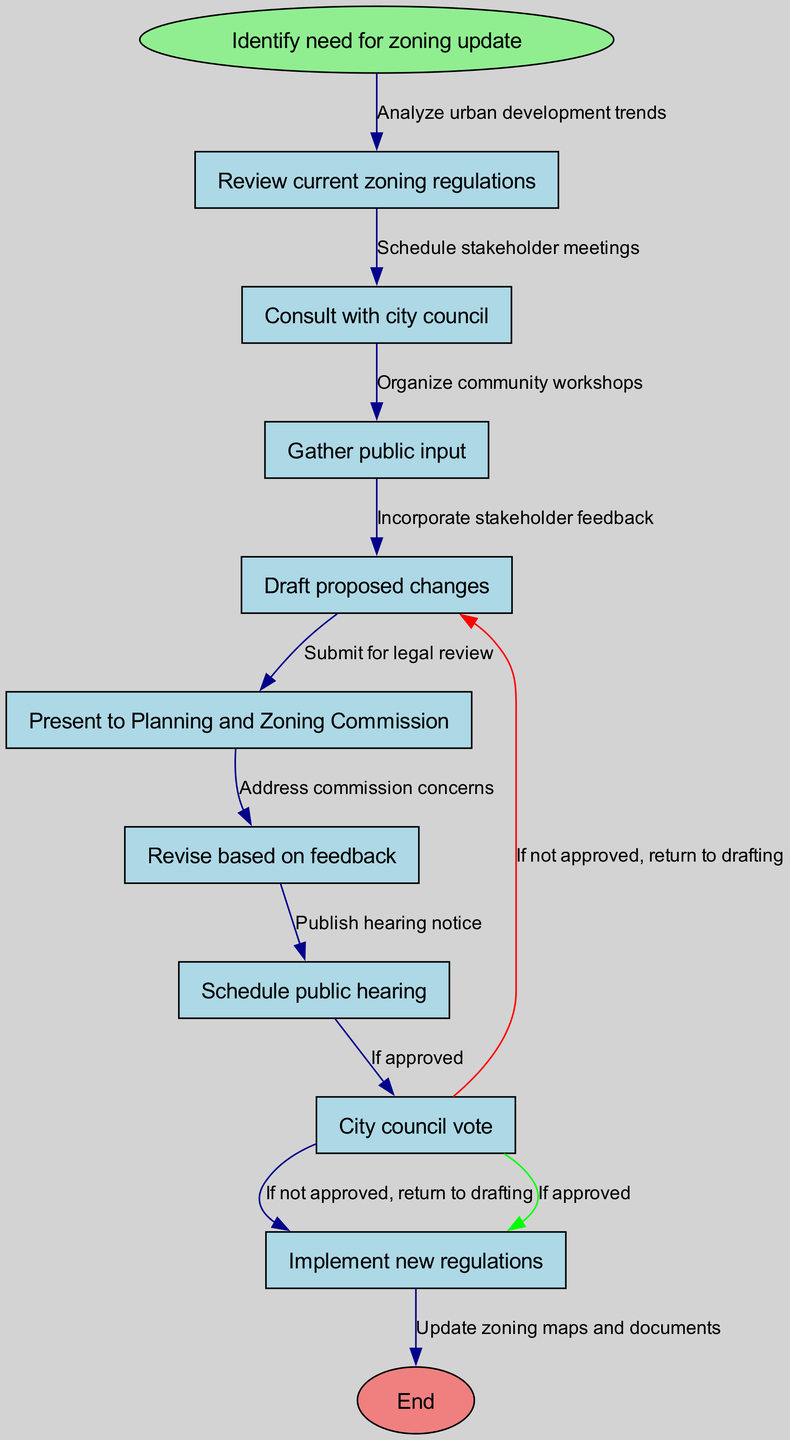What is the first step in the workflow? The first step, according to the diagram, is "Identify need for zoning update." This is clearly marked as the starting point of the flowchart.
Answer: Identify need for zoning update How many nodes are in the diagram? The diagram consists of 10 nodes, which include the start node, 8 action nodes, and the end node. By counting each, we confirm the total as 10.
Answer: 10 What is the last action before the new regulations are implemented? The last action before the implementation of new regulations is the "City council vote." The flow of the diagram leads directly to this action before showing the end.
Answer: City council vote Which step follows "Gather public input"? After "Gather public input," the next step is "Draft proposed changes." This is determined by following the directed edge from "Gather public input" to "Draft proposed changes."
Answer: Draft proposed changes What happens if the city council does not approve the proposed changes? If the city council does not approve, the workflow indicates that you "return to drafting." This is specified with a conditional edge leading back to "Draft proposed changes."
Answer: Return to drafting How are community feedback and concerns addressed in the process? After presenting to the Planning and Zoning Commission, the step "Revise based on feedback" indicates how community feedback and concerns are addressed in the workflow. This implies incorporation of stakeholder input before the next steps.
Answer: Revise based on feedback What is the purpose of the "Schedule public hearing" node? The "Schedule public hearing" node serves as a preparatory step before the "City council vote." It organizes the public forum for discussing the proposed zoning changes, which is critical for community engagement in the process.
Answer: Engage community input What is the relationship between the "Present to Planning and Zoning Commission" and "Revise based on feedback"? The relationship is sequential; "Present to Planning and Zoning Commission" leads directly to "Revise based on feedback." Feedback from the commission prompts the need for revisions, showing a cause-and-effect flow.
Answer: Sequential relationship 